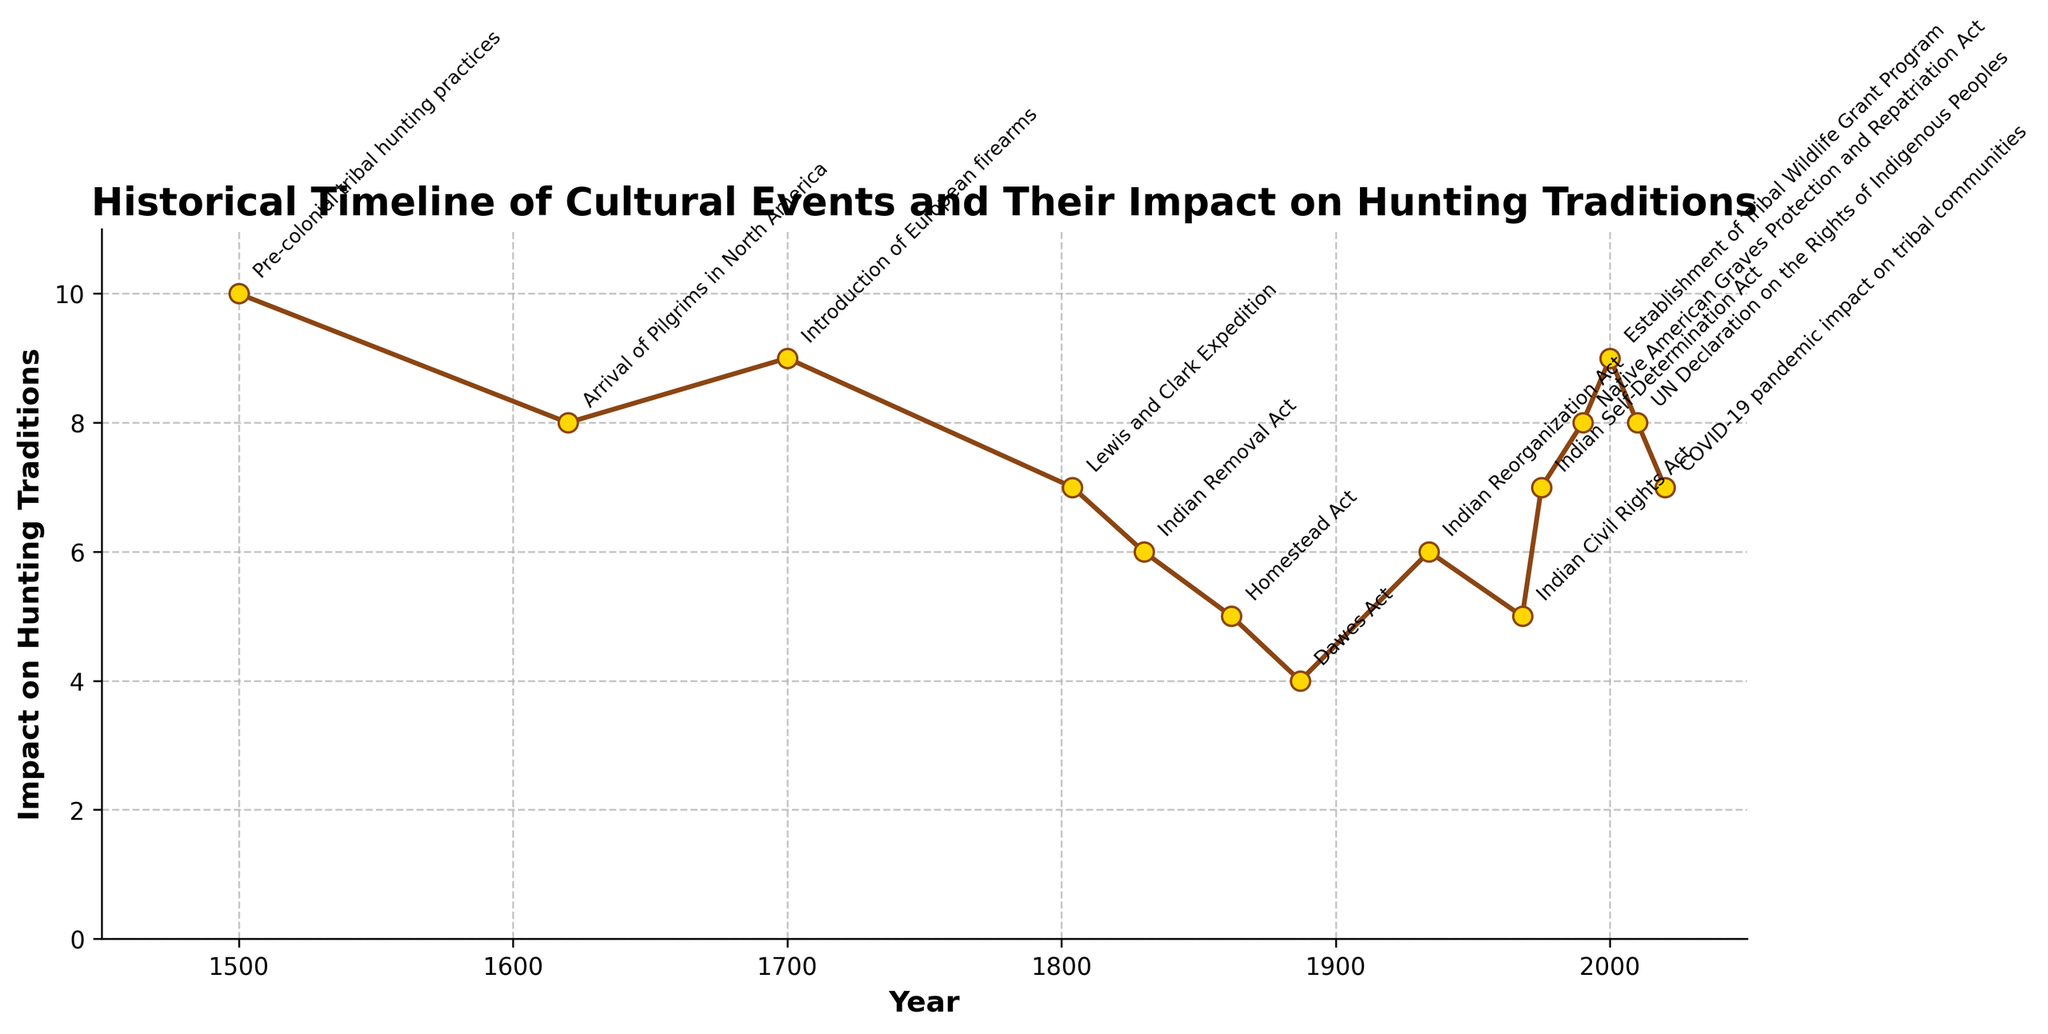What year had the highest impact on hunting traditions according to the figure? Based on the line chart’s highest point, we see that the year 1500 had the highest impact with a score of 10.
Answer: 1500 Which event had the lowest impact on hunting traditions and in what year did it occur? Looking at the lowest point on the line, the Dawes Act in 1887 had the lowest impact on hunting traditions with a score of 4.
Answer: Dawes Act, 1887 How does the impact of the Indian Removal Act in 1830 compare to the impact of the Indian Reorganization Act in 1934? By examining the graph, the Indian Removal Act in 1830 had an impact score of 6, while the Indian Reorganization Act in 1934 had an impact score of 6. Thus, their impacts were equal.
Answer: Equal Is there a general trend in the impact scores from 1500 to 2020? The general trend shows a decrease from the highest impact in 1500 to a lower impact around the 1880s, but then it gradually increases again towards the 2000s.
Answer: Decreasing and then increasing What is the average impact score across all events shown in the figure? There are 14 events with corresponding impact scores of 10, 8, 9, 7, 6, 5, 4, 6, 5, 7, 8, 9, 8, and 7. Summing these gives (10 + 8 + 9 + 7 + 6 + 5 + 4 + 6 + 5 + 7 + 8 + 9 + 8 + 7) = 99. Dividing by 14 gives the average impact score of approximately 7.07.
Answer: 7.07 Between the Indian Civil Rights Act in 1968 and the Indian Self-Determination Act in 1975, which has a higher impact score and by how much? The Indian Civil Rights Act in 1968 has an impact score of 5, whereas the Indian Self-Determination Act in 1975 has an impact score of 7. The difference is 7 - 5 = 2.
Answer: Indian Self-Determination Act, by 2 What is the impact difference between the Homestead Act in 1862 and the UN Declaration on the Rights of Indigenous Peoples in 2010? The impact score for the Homestead Act in 1862 is 5, and the impact score for the UN Declaration in 2010 is 8. The difference is 8 - 5 = 3.
Answer: 3 During which century did the most events listed occur? Counting the events per century, there are 3 in the 1600s, 2 in the 1700s, 4 in the 1800s, 4 in the 1900s, and 2 in the 2000s. The 1800s and 1900s had the most events.
Answer: 1800s and 1900s 